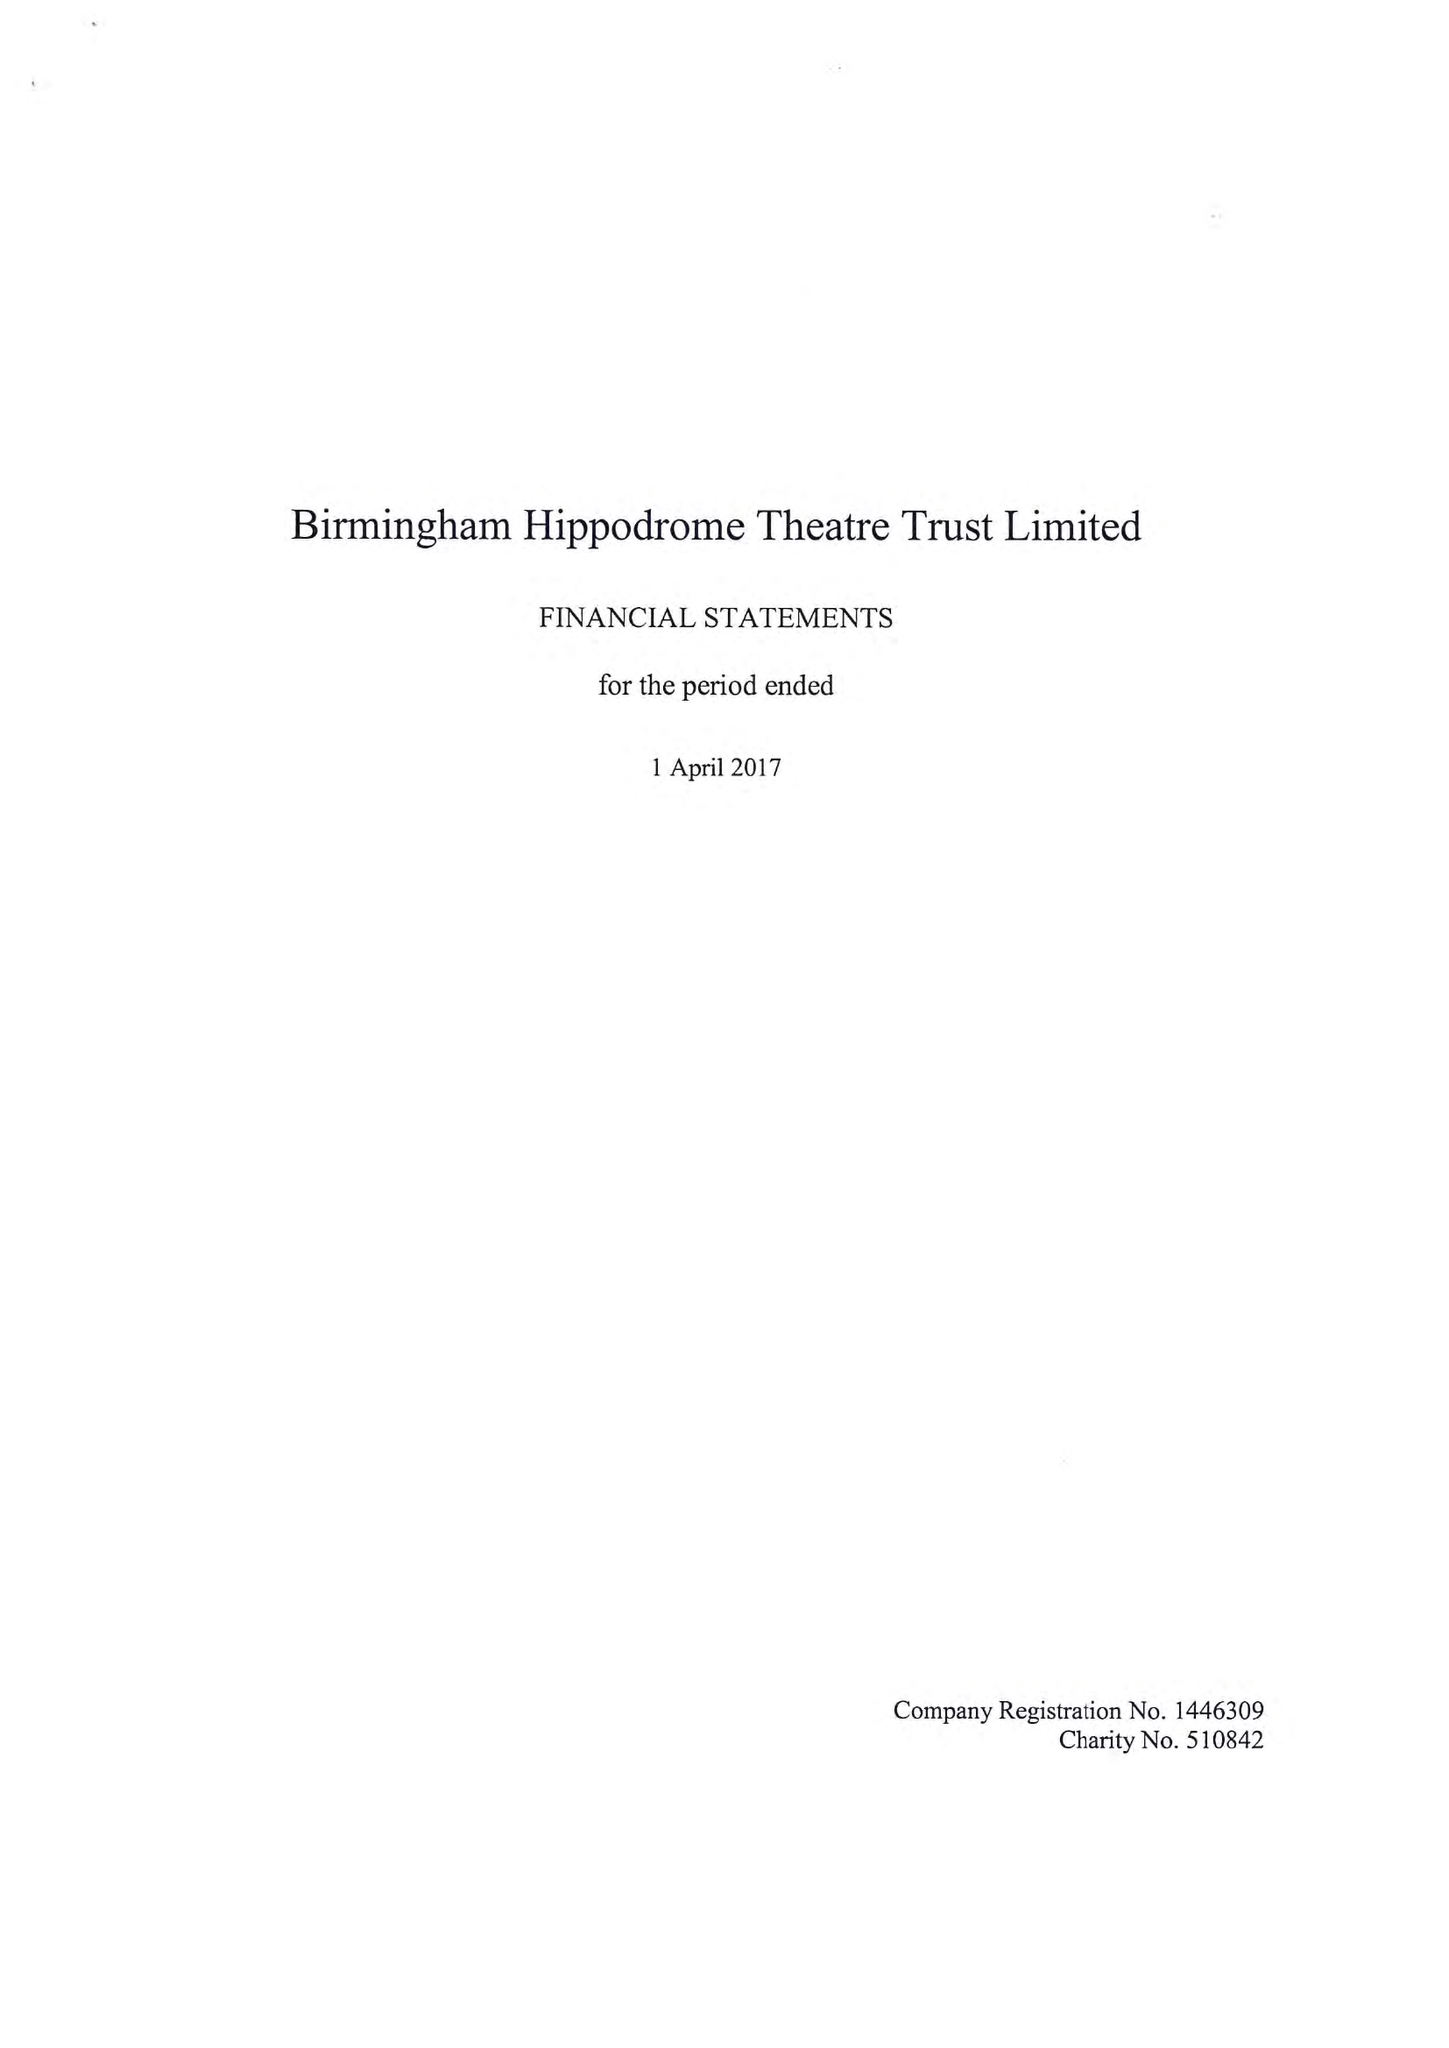What is the value for the charity_name?
Answer the question using a single word or phrase. Birmingham Hippodrome Theatre Trust Ltd. 